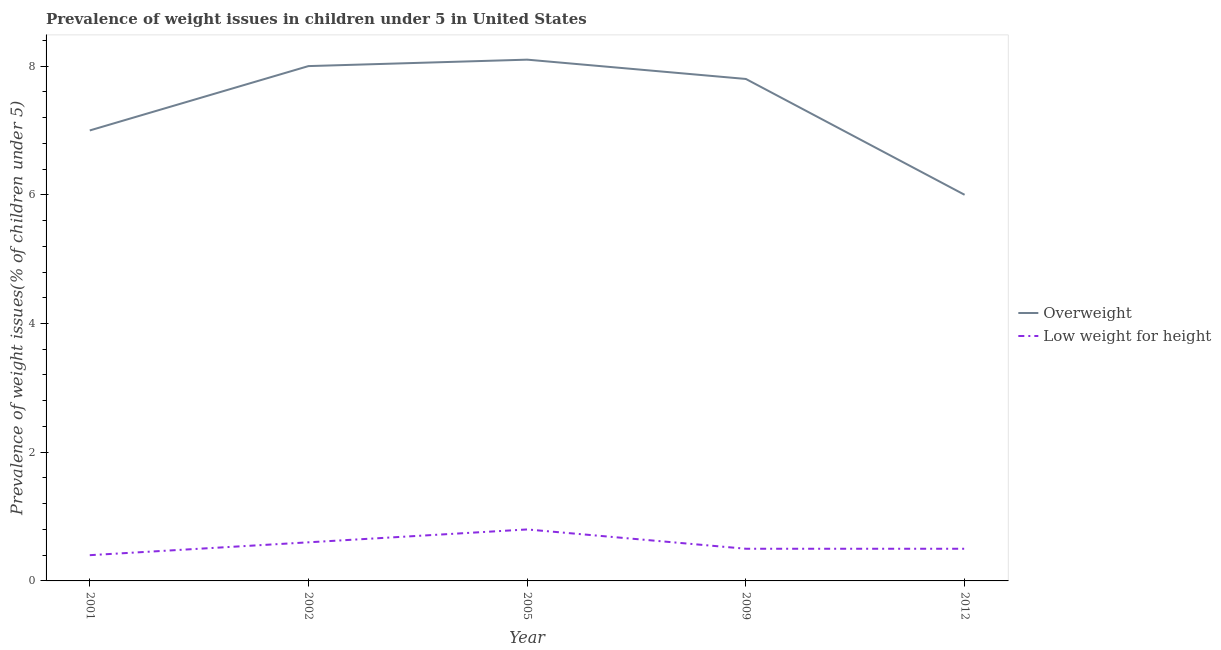How many different coloured lines are there?
Offer a very short reply. 2. Does the line corresponding to percentage of overweight children intersect with the line corresponding to percentage of underweight children?
Your response must be concise. No. Is the number of lines equal to the number of legend labels?
Your answer should be very brief. Yes. What is the percentage of overweight children in 2009?
Offer a very short reply. 7.8. Across all years, what is the maximum percentage of overweight children?
Offer a terse response. 8.1. Across all years, what is the minimum percentage of underweight children?
Keep it short and to the point. 0.4. What is the total percentage of underweight children in the graph?
Offer a terse response. 2.8. What is the difference between the percentage of underweight children in 2001 and that in 2009?
Your response must be concise. -0.1. What is the difference between the percentage of underweight children in 2009 and the percentage of overweight children in 2005?
Ensure brevity in your answer.  -7.6. What is the average percentage of overweight children per year?
Your answer should be very brief. 7.38. In the year 2009, what is the difference between the percentage of overweight children and percentage of underweight children?
Ensure brevity in your answer.  7.3. What is the ratio of the percentage of underweight children in 2005 to that in 2012?
Offer a terse response. 1.6. Is the percentage of overweight children in 2001 less than that in 2009?
Keep it short and to the point. Yes. Is the difference between the percentage of overweight children in 2001 and 2012 greater than the difference between the percentage of underweight children in 2001 and 2012?
Keep it short and to the point. Yes. What is the difference between the highest and the second highest percentage of underweight children?
Your answer should be very brief. 0.2. What is the difference between the highest and the lowest percentage of underweight children?
Your answer should be very brief. 0.4. Is the sum of the percentage of overweight children in 2002 and 2009 greater than the maximum percentage of underweight children across all years?
Keep it short and to the point. Yes. Does the percentage of overweight children monotonically increase over the years?
Give a very brief answer. No. Is the percentage of overweight children strictly greater than the percentage of underweight children over the years?
Your answer should be compact. Yes. Is the percentage of underweight children strictly less than the percentage of overweight children over the years?
Your response must be concise. Yes. What is the difference between two consecutive major ticks on the Y-axis?
Your answer should be very brief. 2. Does the graph contain any zero values?
Give a very brief answer. No. Does the graph contain grids?
Your response must be concise. No. Where does the legend appear in the graph?
Provide a short and direct response. Center right. How are the legend labels stacked?
Keep it short and to the point. Vertical. What is the title of the graph?
Provide a short and direct response. Prevalence of weight issues in children under 5 in United States. Does "Mineral" appear as one of the legend labels in the graph?
Your answer should be very brief. No. What is the label or title of the Y-axis?
Your answer should be compact. Prevalence of weight issues(% of children under 5). What is the Prevalence of weight issues(% of children under 5) in Overweight in 2001?
Offer a very short reply. 7. What is the Prevalence of weight issues(% of children under 5) in Low weight for height in 2001?
Your answer should be very brief. 0.4. What is the Prevalence of weight issues(% of children under 5) in Low weight for height in 2002?
Keep it short and to the point. 0.6. What is the Prevalence of weight issues(% of children under 5) in Overweight in 2005?
Provide a succinct answer. 8.1. What is the Prevalence of weight issues(% of children under 5) of Low weight for height in 2005?
Keep it short and to the point. 0.8. What is the Prevalence of weight issues(% of children under 5) of Overweight in 2009?
Your answer should be very brief. 7.8. What is the Prevalence of weight issues(% of children under 5) in Low weight for height in 2009?
Provide a short and direct response. 0.5. What is the Prevalence of weight issues(% of children under 5) of Low weight for height in 2012?
Offer a terse response. 0.5. Across all years, what is the maximum Prevalence of weight issues(% of children under 5) in Overweight?
Offer a terse response. 8.1. Across all years, what is the maximum Prevalence of weight issues(% of children under 5) of Low weight for height?
Make the answer very short. 0.8. Across all years, what is the minimum Prevalence of weight issues(% of children under 5) in Overweight?
Make the answer very short. 6. Across all years, what is the minimum Prevalence of weight issues(% of children under 5) of Low weight for height?
Provide a succinct answer. 0.4. What is the total Prevalence of weight issues(% of children under 5) of Overweight in the graph?
Offer a terse response. 36.9. What is the difference between the Prevalence of weight issues(% of children under 5) in Overweight in 2001 and that in 2002?
Give a very brief answer. -1. What is the difference between the Prevalence of weight issues(% of children under 5) in Overweight in 2001 and that in 2005?
Ensure brevity in your answer.  -1.1. What is the difference between the Prevalence of weight issues(% of children under 5) in Low weight for height in 2001 and that in 2009?
Offer a terse response. -0.1. What is the difference between the Prevalence of weight issues(% of children under 5) in Low weight for height in 2001 and that in 2012?
Provide a succinct answer. -0.1. What is the difference between the Prevalence of weight issues(% of children under 5) in Low weight for height in 2002 and that in 2005?
Provide a succinct answer. -0.2. What is the difference between the Prevalence of weight issues(% of children under 5) in Low weight for height in 2002 and that in 2009?
Your answer should be compact. 0.1. What is the difference between the Prevalence of weight issues(% of children under 5) in Overweight in 2005 and that in 2012?
Your answer should be very brief. 2.1. What is the difference between the Prevalence of weight issues(% of children under 5) of Low weight for height in 2005 and that in 2012?
Provide a short and direct response. 0.3. What is the difference between the Prevalence of weight issues(% of children under 5) in Overweight in 2009 and that in 2012?
Make the answer very short. 1.8. What is the difference between the Prevalence of weight issues(% of children under 5) of Low weight for height in 2009 and that in 2012?
Keep it short and to the point. 0. What is the difference between the Prevalence of weight issues(% of children under 5) of Overweight in 2001 and the Prevalence of weight issues(% of children under 5) of Low weight for height in 2009?
Keep it short and to the point. 6.5. What is the difference between the Prevalence of weight issues(% of children under 5) of Overweight in 2001 and the Prevalence of weight issues(% of children under 5) of Low weight for height in 2012?
Make the answer very short. 6.5. What is the difference between the Prevalence of weight issues(% of children under 5) in Overweight in 2002 and the Prevalence of weight issues(% of children under 5) in Low weight for height in 2005?
Offer a very short reply. 7.2. What is the difference between the Prevalence of weight issues(% of children under 5) in Overweight in 2002 and the Prevalence of weight issues(% of children under 5) in Low weight for height in 2009?
Offer a terse response. 7.5. What is the difference between the Prevalence of weight issues(% of children under 5) of Overweight in 2002 and the Prevalence of weight issues(% of children under 5) of Low weight for height in 2012?
Your answer should be very brief. 7.5. What is the difference between the Prevalence of weight issues(% of children under 5) of Overweight in 2005 and the Prevalence of weight issues(% of children under 5) of Low weight for height in 2009?
Ensure brevity in your answer.  7.6. What is the difference between the Prevalence of weight issues(% of children under 5) of Overweight in 2009 and the Prevalence of weight issues(% of children under 5) of Low weight for height in 2012?
Ensure brevity in your answer.  7.3. What is the average Prevalence of weight issues(% of children under 5) of Overweight per year?
Ensure brevity in your answer.  7.38. What is the average Prevalence of weight issues(% of children under 5) of Low weight for height per year?
Provide a succinct answer. 0.56. In the year 2009, what is the difference between the Prevalence of weight issues(% of children under 5) of Overweight and Prevalence of weight issues(% of children under 5) of Low weight for height?
Your answer should be compact. 7.3. In the year 2012, what is the difference between the Prevalence of weight issues(% of children under 5) in Overweight and Prevalence of weight issues(% of children under 5) in Low weight for height?
Your answer should be very brief. 5.5. What is the ratio of the Prevalence of weight issues(% of children under 5) in Overweight in 2001 to that in 2002?
Offer a terse response. 0.88. What is the ratio of the Prevalence of weight issues(% of children under 5) of Overweight in 2001 to that in 2005?
Keep it short and to the point. 0.86. What is the ratio of the Prevalence of weight issues(% of children under 5) of Low weight for height in 2001 to that in 2005?
Your answer should be very brief. 0.5. What is the ratio of the Prevalence of weight issues(% of children under 5) in Overweight in 2001 to that in 2009?
Offer a terse response. 0.9. What is the ratio of the Prevalence of weight issues(% of children under 5) in Overweight in 2001 to that in 2012?
Your answer should be compact. 1.17. What is the ratio of the Prevalence of weight issues(% of children under 5) of Low weight for height in 2002 to that in 2005?
Your response must be concise. 0.75. What is the ratio of the Prevalence of weight issues(% of children under 5) of Overweight in 2002 to that in 2009?
Make the answer very short. 1.03. What is the ratio of the Prevalence of weight issues(% of children under 5) of Overweight in 2002 to that in 2012?
Ensure brevity in your answer.  1.33. What is the ratio of the Prevalence of weight issues(% of children under 5) in Overweight in 2005 to that in 2009?
Provide a short and direct response. 1.04. What is the ratio of the Prevalence of weight issues(% of children under 5) in Low weight for height in 2005 to that in 2009?
Provide a short and direct response. 1.6. What is the ratio of the Prevalence of weight issues(% of children under 5) in Overweight in 2005 to that in 2012?
Keep it short and to the point. 1.35. What is the ratio of the Prevalence of weight issues(% of children under 5) of Low weight for height in 2005 to that in 2012?
Provide a succinct answer. 1.6. What is the ratio of the Prevalence of weight issues(% of children under 5) of Overweight in 2009 to that in 2012?
Give a very brief answer. 1.3. What is the difference between the highest and the second highest Prevalence of weight issues(% of children under 5) in Overweight?
Make the answer very short. 0.1. What is the difference between the highest and the second highest Prevalence of weight issues(% of children under 5) in Low weight for height?
Your response must be concise. 0.2. What is the difference between the highest and the lowest Prevalence of weight issues(% of children under 5) in Overweight?
Your response must be concise. 2.1. What is the difference between the highest and the lowest Prevalence of weight issues(% of children under 5) in Low weight for height?
Your response must be concise. 0.4. 